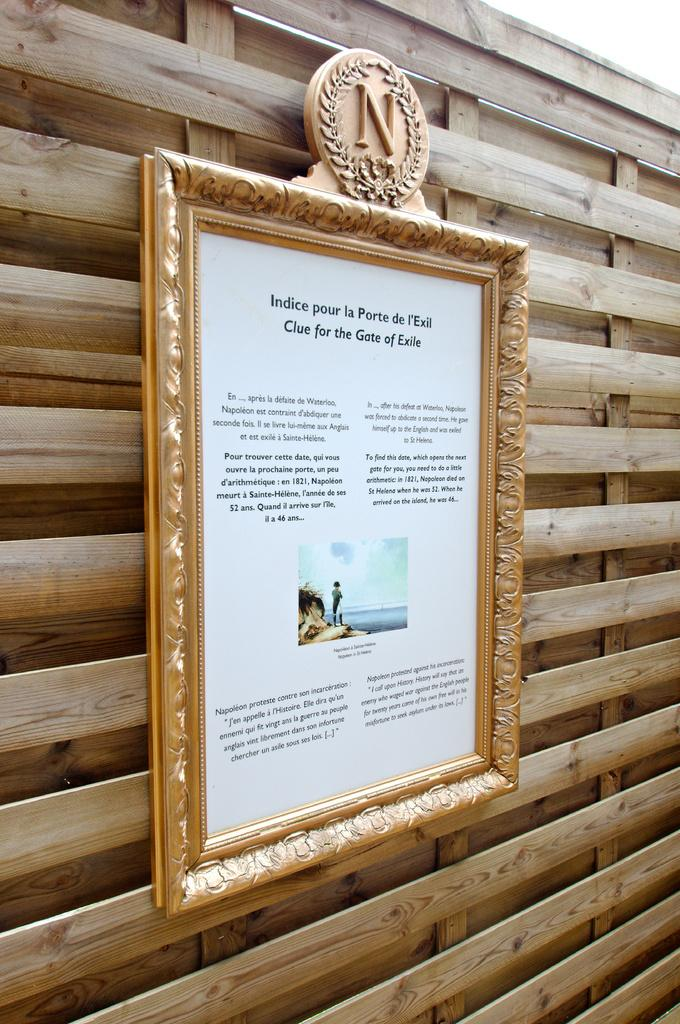Provide a one-sentence caption for the provided image. A frame picture on a wooden wall with the letter N on top. 